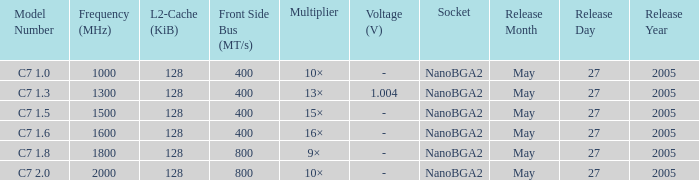What is the Front Side Bus for Model Number c7 1.5? 400 MT/s. 